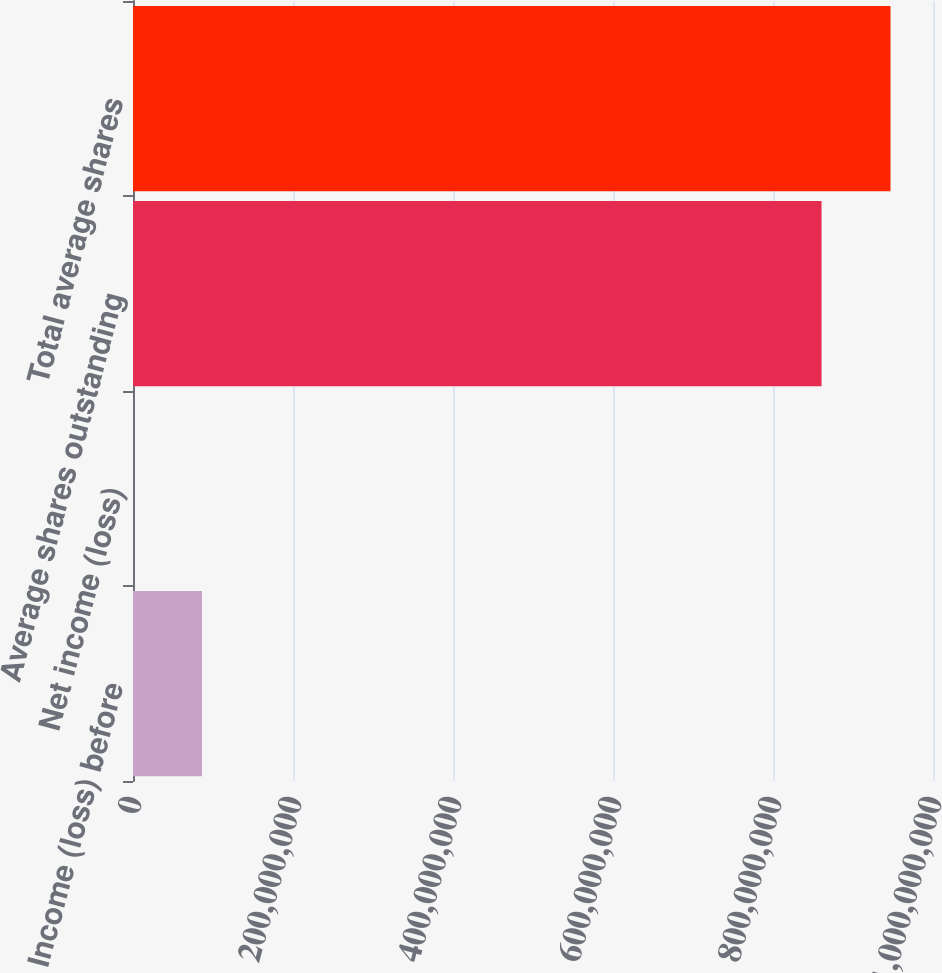Convert chart to OTSL. <chart><loc_0><loc_0><loc_500><loc_500><bar_chart><fcel>Income (loss) before<fcel>Net income (loss)<fcel>Average shares outstanding<fcel>Total average shares<nl><fcel>8.62107e+07<fcel>1324<fcel>8.60671e+08<fcel>9.46881e+08<nl></chart> 